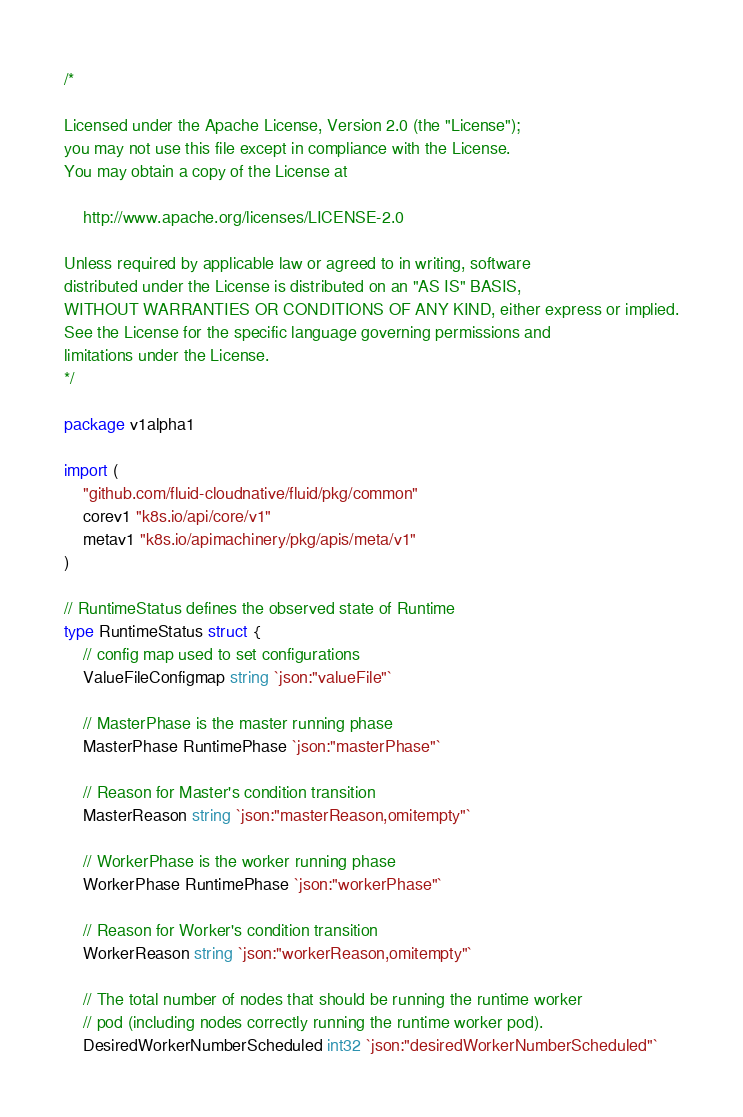Convert code to text. <code><loc_0><loc_0><loc_500><loc_500><_Go_>/*

Licensed under the Apache License, Version 2.0 (the "License");
you may not use this file except in compliance with the License.
You may obtain a copy of the License at

    http://www.apache.org/licenses/LICENSE-2.0

Unless required by applicable law or agreed to in writing, software
distributed under the License is distributed on an "AS IS" BASIS,
WITHOUT WARRANTIES OR CONDITIONS OF ANY KIND, either express or implied.
See the License for the specific language governing permissions and
limitations under the License.
*/

package v1alpha1

import (
	"github.com/fluid-cloudnative/fluid/pkg/common"
	corev1 "k8s.io/api/core/v1"
	metav1 "k8s.io/apimachinery/pkg/apis/meta/v1"
)

// RuntimeStatus defines the observed state of Runtime
type RuntimeStatus struct {
	// config map used to set configurations
	ValueFileConfigmap string `json:"valueFile"`

	// MasterPhase is the master running phase
	MasterPhase RuntimePhase `json:"masterPhase"`

	// Reason for Master's condition transition
	MasterReason string `json:"masterReason,omitempty"`

	// WorkerPhase is the worker running phase
	WorkerPhase RuntimePhase `json:"workerPhase"`

	// Reason for Worker's condition transition
	WorkerReason string `json:"workerReason,omitempty"`

	// The total number of nodes that should be running the runtime worker
	// pod (including nodes correctly running the runtime worker pod).
	DesiredWorkerNumberScheduled int32 `json:"desiredWorkerNumberScheduled"`
</code> 